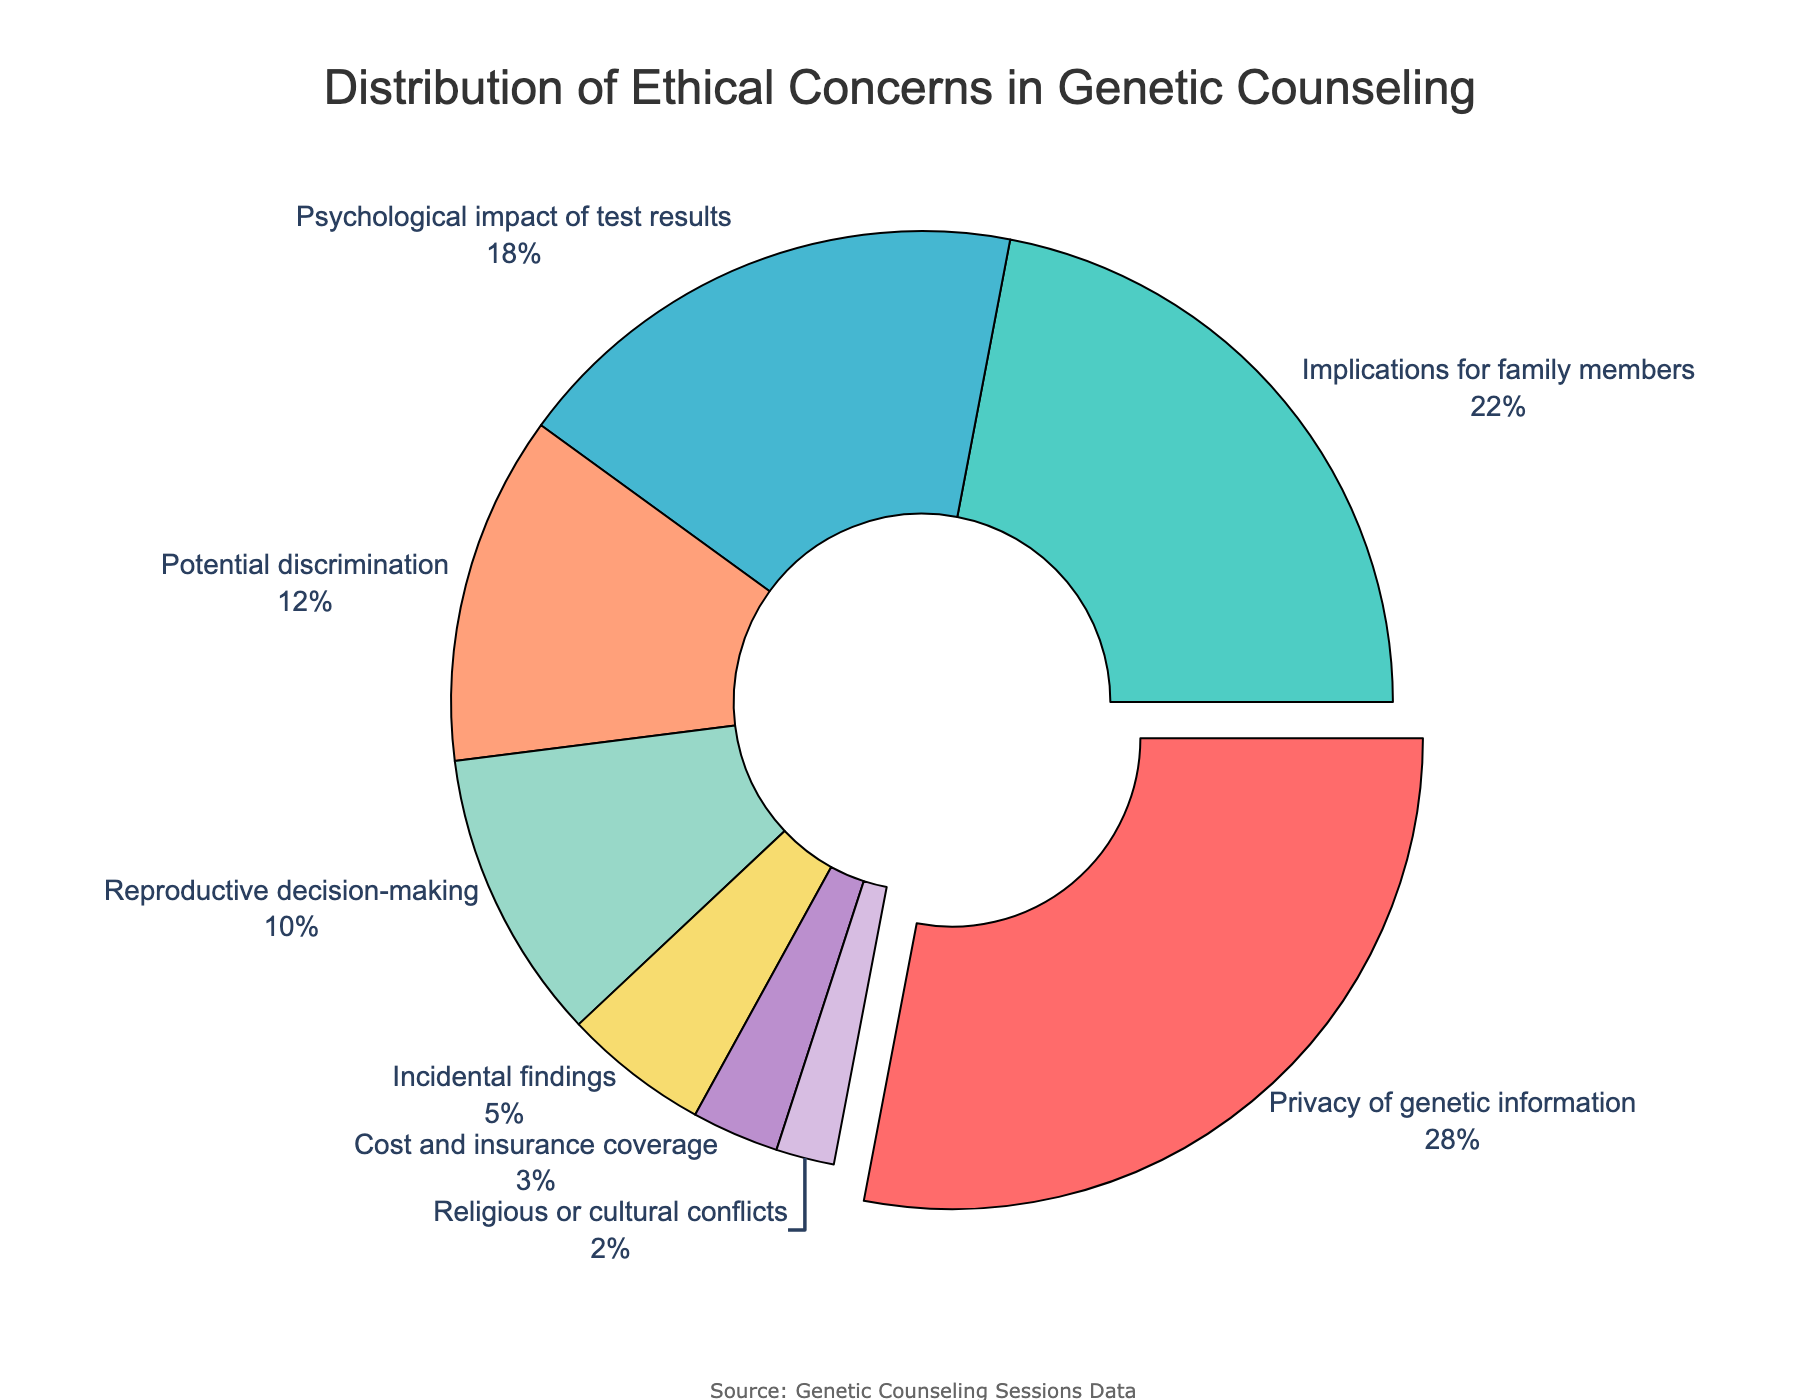What is the most common ethical concern in genetic counseling sessions? The most common ethical concern is represented by the largest segment in the pie chart. The label shows that "Privacy of genetic information" is the largest with 28%.
Answer: Privacy of genetic information Which concern has the second highest percentage? The second-largest segment in the pie chart shows the label "Implications for family members" with 22%.
Answer: Implications for family members How many concerns have a percentage of 10% or lower? By examining the segments, we see that "Reproductive decision-making" (10%), "Incidental findings" (5%), "Cost and insurance coverage" (3%), and "Religious or cultural conflicts" (2%) have percentages of 10% or lower. There are 4 such concerns.
Answer: 4 What is the combined percentage of "Potential discrimination" and "Psychological impact of test results"? By summing their percentages: "Potential discrimination" (12%) + "Psychological impact of test results" (18%) = 30%.
Answer: 30% Which segment of the pie chart is highlighted by being slightly pulled out? The segment that is visibly pulled out represents "Privacy of genetic information".
Answer: Privacy of genetic information Is "Reproductive decision-making" more or less common than "Potential discrimination" according to the chart? By comparing the sizes, "Reproductive decision-making" (10%) is less common than "Potential discrimination" (12%).
Answer: Less common Which concerns together make up a quarter (25%) of the total percentage? The concerns "Incidental findings" (5%), "Cost and insurance coverage" (3%), and "Religious or cultural conflicts" (2%) sum up to 10%, which isn't enough. Adding "Reproductive decision-making" (10%) gives a total of 20%. Adding "Potential discrimination" (12%) makes the total 32%. The closest match without going over is 20%.
Answer: None, less than 25% is possible What is the smallest percentage depicted in the pie chart, and which concern does it represent? The smallest segment in the pie chart has a label showing 2%, which represents "Religious or cultural conflicts".
Answer: Religious or cultural conflicts What are the percentages for concerns related to family members and psychological impact of test results combined? Adding their respective percentages 22% (Implications for family members) and 18% (Psychological impact of test results): 22% + 18% = 40%.
Answer: 40% Estimate the difference between percentages of "Privacy of genetic information" and "Implications for family members". Subtracting their percentages: 28% (Privacy of genetic information) - 22% (Implications for family members) = 6%.
Answer: 6% 